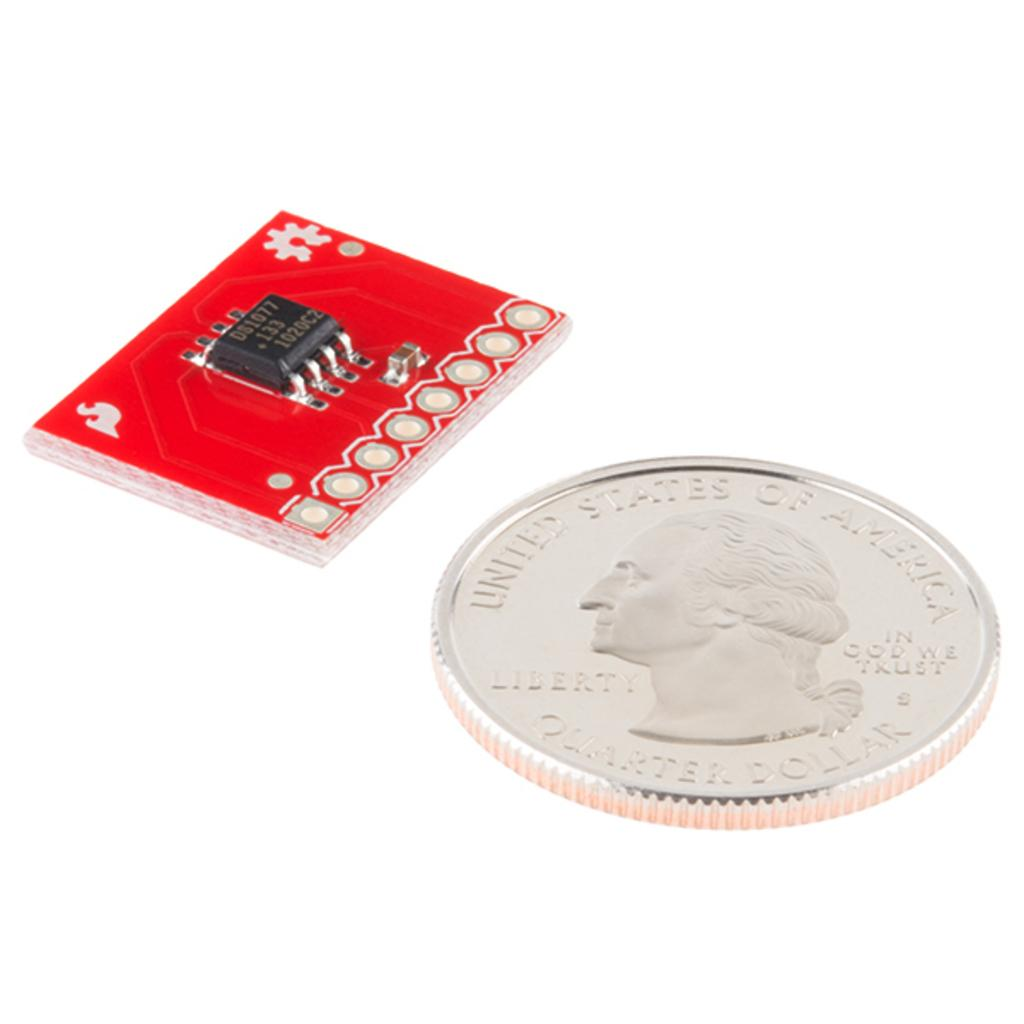What is the main subject of the image? The main subject of the image is an electronic chip. Can you describe the colors of the electronic chip? The electronic chip has red, white, silver, and black colors. What other object is present in the image? There is a coin in the image. What is depicted on the coin? The coin has a person's face on it. What color is the background of the image? The background of the image is white. Can you tell me how much milk the pump is producing in the image? There is no pump or milk present in the image; it features an electronic chip and a coin. Is there a picture of a cow on the electronic chip? There is no picture of a cow on the electronic chip; it has red, white, silver, and black colors. 